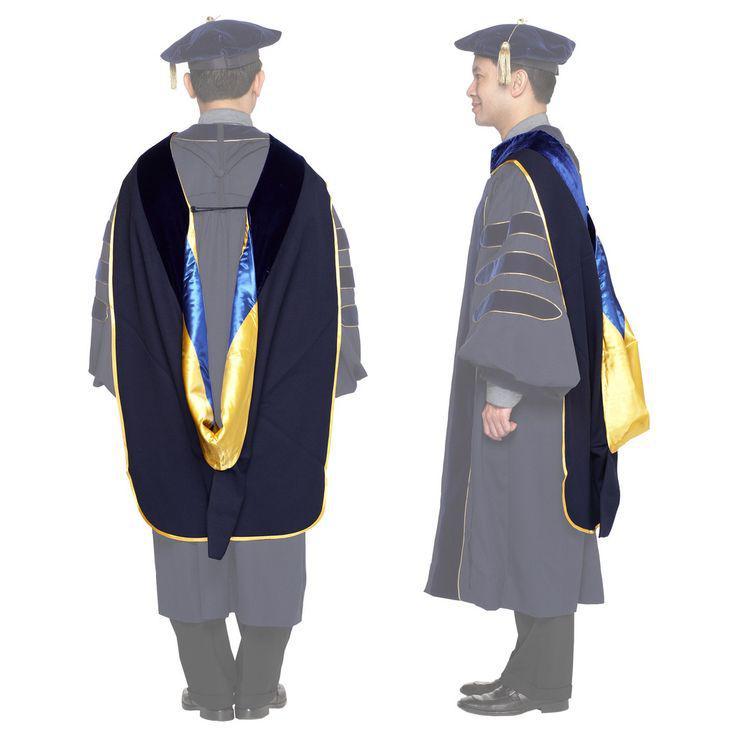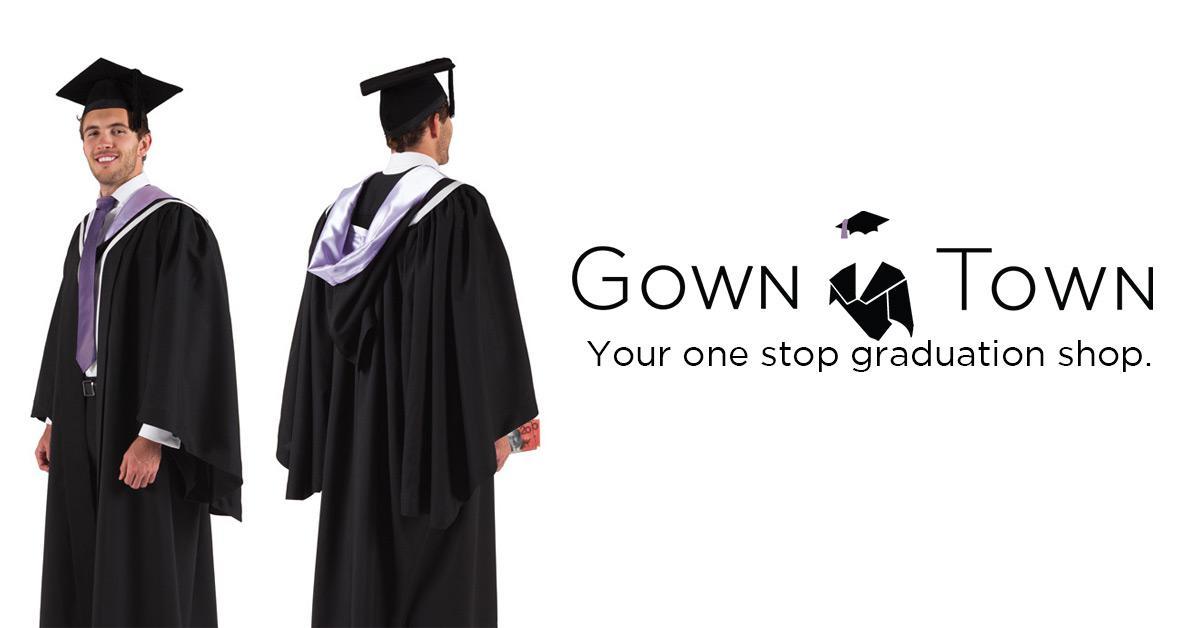The first image is the image on the left, the second image is the image on the right. Given the left and right images, does the statement "Each image includes a backward-facing male modeling graduation attire." hold true? Answer yes or no. Yes. The first image is the image on the left, the second image is the image on the right. Given the left and right images, does the statement "All caps and gowns in the images are modeled by actual people who are shown in full length, from head to toe." hold true? Answer yes or no. No. 